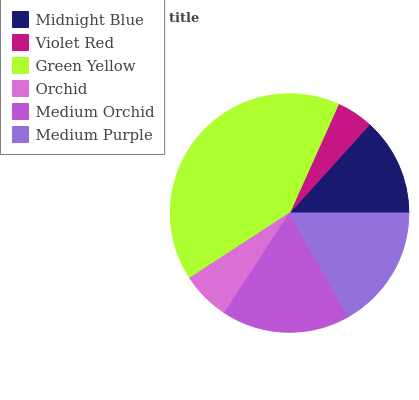Is Violet Red the minimum?
Answer yes or no. Yes. Is Green Yellow the maximum?
Answer yes or no. Yes. Is Green Yellow the minimum?
Answer yes or no. No. Is Violet Red the maximum?
Answer yes or no. No. Is Green Yellow greater than Violet Red?
Answer yes or no. Yes. Is Violet Red less than Green Yellow?
Answer yes or no. Yes. Is Violet Red greater than Green Yellow?
Answer yes or no. No. Is Green Yellow less than Violet Red?
Answer yes or no. No. Is Medium Purple the high median?
Answer yes or no. Yes. Is Midnight Blue the low median?
Answer yes or no. Yes. Is Orchid the high median?
Answer yes or no. No. Is Green Yellow the low median?
Answer yes or no. No. 